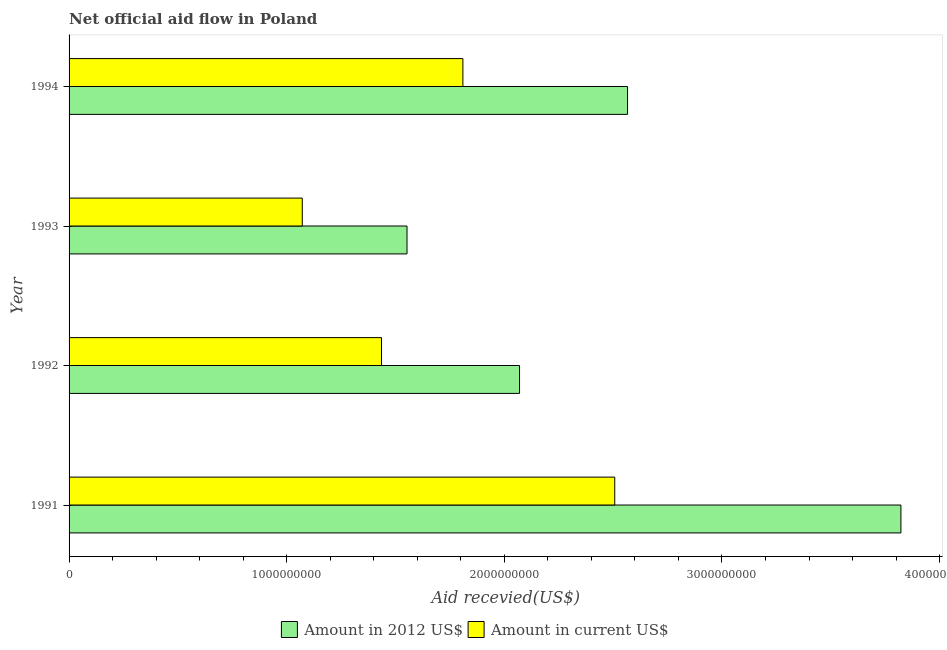How many different coloured bars are there?
Your response must be concise. 2. How many groups of bars are there?
Your answer should be very brief. 4. What is the amount of aid received(expressed in 2012 us$) in 1991?
Provide a short and direct response. 3.82e+09. Across all years, what is the maximum amount of aid received(expressed in us$)?
Your response must be concise. 2.51e+09. Across all years, what is the minimum amount of aid received(expressed in us$)?
Keep it short and to the point. 1.07e+09. What is the total amount of aid received(expressed in 2012 us$) in the graph?
Your answer should be compact. 1.00e+1. What is the difference between the amount of aid received(expressed in 2012 us$) in 1991 and that in 1994?
Ensure brevity in your answer.  1.26e+09. What is the difference between the amount of aid received(expressed in us$) in 1991 and the amount of aid received(expressed in 2012 us$) in 1994?
Offer a terse response. -5.88e+07. What is the average amount of aid received(expressed in 2012 us$) per year?
Offer a very short reply. 2.50e+09. In the year 1992, what is the difference between the amount of aid received(expressed in us$) and amount of aid received(expressed in 2012 us$)?
Your answer should be compact. -6.34e+08. In how many years, is the amount of aid received(expressed in us$) greater than 200000000 US$?
Offer a very short reply. 4. What is the ratio of the amount of aid received(expressed in 2012 us$) in 1992 to that in 1994?
Provide a succinct answer. 0.81. Is the difference between the amount of aid received(expressed in 2012 us$) in 1993 and 1994 greater than the difference between the amount of aid received(expressed in us$) in 1993 and 1994?
Give a very brief answer. No. What is the difference between the highest and the second highest amount of aid received(expressed in 2012 us$)?
Offer a terse response. 1.26e+09. What is the difference between the highest and the lowest amount of aid received(expressed in us$)?
Provide a succinct answer. 1.44e+09. In how many years, is the amount of aid received(expressed in 2012 us$) greater than the average amount of aid received(expressed in 2012 us$) taken over all years?
Ensure brevity in your answer.  2. Is the sum of the amount of aid received(expressed in us$) in 1991 and 1992 greater than the maximum amount of aid received(expressed in 2012 us$) across all years?
Ensure brevity in your answer.  Yes. What does the 1st bar from the top in 1991 represents?
Your response must be concise. Amount in current US$. What does the 1st bar from the bottom in 1991 represents?
Provide a succinct answer. Amount in 2012 US$. Are all the bars in the graph horizontal?
Keep it short and to the point. Yes. How many years are there in the graph?
Give a very brief answer. 4. What is the difference between two consecutive major ticks on the X-axis?
Your response must be concise. 1.00e+09. Are the values on the major ticks of X-axis written in scientific E-notation?
Provide a succinct answer. No. Does the graph contain any zero values?
Your response must be concise. No. Does the graph contain grids?
Your answer should be compact. No. How many legend labels are there?
Keep it short and to the point. 2. How are the legend labels stacked?
Offer a very short reply. Horizontal. What is the title of the graph?
Keep it short and to the point. Net official aid flow in Poland. Does "Under-five" appear as one of the legend labels in the graph?
Provide a short and direct response. No. What is the label or title of the X-axis?
Provide a short and direct response. Aid recevied(US$). What is the label or title of the Y-axis?
Make the answer very short. Year. What is the Aid recevied(US$) of Amount in 2012 US$ in 1991?
Provide a succinct answer. 3.82e+09. What is the Aid recevied(US$) of Amount in current US$ in 1991?
Your answer should be very brief. 2.51e+09. What is the Aid recevied(US$) of Amount in 2012 US$ in 1992?
Provide a short and direct response. 2.07e+09. What is the Aid recevied(US$) of Amount in current US$ in 1992?
Offer a terse response. 1.44e+09. What is the Aid recevied(US$) of Amount in 2012 US$ in 1993?
Give a very brief answer. 1.55e+09. What is the Aid recevied(US$) in Amount in current US$ in 1993?
Your answer should be compact. 1.07e+09. What is the Aid recevied(US$) in Amount in 2012 US$ in 1994?
Ensure brevity in your answer.  2.57e+09. What is the Aid recevied(US$) in Amount in current US$ in 1994?
Give a very brief answer. 1.81e+09. Across all years, what is the maximum Aid recevied(US$) of Amount in 2012 US$?
Give a very brief answer. 3.82e+09. Across all years, what is the maximum Aid recevied(US$) of Amount in current US$?
Offer a very short reply. 2.51e+09. Across all years, what is the minimum Aid recevied(US$) of Amount in 2012 US$?
Ensure brevity in your answer.  1.55e+09. Across all years, what is the minimum Aid recevied(US$) of Amount in current US$?
Your response must be concise. 1.07e+09. What is the total Aid recevied(US$) of Amount in 2012 US$ in the graph?
Keep it short and to the point. 1.00e+1. What is the total Aid recevied(US$) of Amount in current US$ in the graph?
Provide a succinct answer. 6.82e+09. What is the difference between the Aid recevied(US$) of Amount in 2012 US$ in 1991 and that in 1992?
Your answer should be compact. 1.75e+09. What is the difference between the Aid recevied(US$) in Amount in current US$ in 1991 and that in 1992?
Keep it short and to the point. 1.07e+09. What is the difference between the Aid recevied(US$) of Amount in 2012 US$ in 1991 and that in 1993?
Keep it short and to the point. 2.27e+09. What is the difference between the Aid recevied(US$) of Amount in current US$ in 1991 and that in 1993?
Give a very brief answer. 1.44e+09. What is the difference between the Aid recevied(US$) of Amount in 2012 US$ in 1991 and that in 1994?
Your response must be concise. 1.26e+09. What is the difference between the Aid recevied(US$) of Amount in current US$ in 1991 and that in 1994?
Your response must be concise. 6.98e+08. What is the difference between the Aid recevied(US$) of Amount in 2012 US$ in 1992 and that in 1993?
Keep it short and to the point. 5.17e+08. What is the difference between the Aid recevied(US$) in Amount in current US$ in 1992 and that in 1993?
Provide a succinct answer. 3.64e+08. What is the difference between the Aid recevied(US$) of Amount in 2012 US$ in 1992 and that in 1994?
Ensure brevity in your answer.  -4.96e+08. What is the difference between the Aid recevied(US$) in Amount in current US$ in 1992 and that in 1994?
Provide a short and direct response. -3.74e+08. What is the difference between the Aid recevied(US$) of Amount in 2012 US$ in 1993 and that in 1994?
Make the answer very short. -1.01e+09. What is the difference between the Aid recevied(US$) of Amount in current US$ in 1993 and that in 1994?
Keep it short and to the point. -7.38e+08. What is the difference between the Aid recevied(US$) in Amount in 2012 US$ in 1991 and the Aid recevied(US$) in Amount in current US$ in 1992?
Keep it short and to the point. 2.39e+09. What is the difference between the Aid recevied(US$) of Amount in 2012 US$ in 1991 and the Aid recevied(US$) of Amount in current US$ in 1993?
Provide a succinct answer. 2.75e+09. What is the difference between the Aid recevied(US$) in Amount in 2012 US$ in 1991 and the Aid recevied(US$) in Amount in current US$ in 1994?
Ensure brevity in your answer.  2.01e+09. What is the difference between the Aid recevied(US$) in Amount in 2012 US$ in 1992 and the Aid recevied(US$) in Amount in current US$ in 1993?
Give a very brief answer. 9.98e+08. What is the difference between the Aid recevied(US$) of Amount in 2012 US$ in 1992 and the Aid recevied(US$) of Amount in current US$ in 1994?
Offer a very short reply. 2.60e+08. What is the difference between the Aid recevied(US$) in Amount in 2012 US$ in 1993 and the Aid recevied(US$) in Amount in current US$ in 1994?
Provide a succinct answer. -2.57e+08. What is the average Aid recevied(US$) in Amount in 2012 US$ per year?
Your answer should be very brief. 2.50e+09. What is the average Aid recevied(US$) in Amount in current US$ per year?
Your answer should be compact. 1.71e+09. In the year 1991, what is the difference between the Aid recevied(US$) in Amount in 2012 US$ and Aid recevied(US$) in Amount in current US$?
Offer a terse response. 1.31e+09. In the year 1992, what is the difference between the Aid recevied(US$) in Amount in 2012 US$ and Aid recevied(US$) in Amount in current US$?
Your response must be concise. 6.34e+08. In the year 1993, what is the difference between the Aid recevied(US$) in Amount in 2012 US$ and Aid recevied(US$) in Amount in current US$?
Ensure brevity in your answer.  4.81e+08. In the year 1994, what is the difference between the Aid recevied(US$) in Amount in 2012 US$ and Aid recevied(US$) in Amount in current US$?
Keep it short and to the point. 7.57e+08. What is the ratio of the Aid recevied(US$) of Amount in 2012 US$ in 1991 to that in 1992?
Your answer should be very brief. 1.85. What is the ratio of the Aid recevied(US$) of Amount in current US$ in 1991 to that in 1992?
Offer a terse response. 1.75. What is the ratio of the Aid recevied(US$) in Amount in 2012 US$ in 1991 to that in 1993?
Ensure brevity in your answer.  2.46. What is the ratio of the Aid recevied(US$) in Amount in current US$ in 1991 to that in 1993?
Provide a succinct answer. 2.34. What is the ratio of the Aid recevied(US$) of Amount in 2012 US$ in 1991 to that in 1994?
Provide a short and direct response. 1.49. What is the ratio of the Aid recevied(US$) in Amount in current US$ in 1991 to that in 1994?
Keep it short and to the point. 1.39. What is the ratio of the Aid recevied(US$) in Amount in 2012 US$ in 1992 to that in 1993?
Offer a very short reply. 1.33. What is the ratio of the Aid recevied(US$) in Amount in current US$ in 1992 to that in 1993?
Offer a very short reply. 1.34. What is the ratio of the Aid recevied(US$) in Amount in 2012 US$ in 1992 to that in 1994?
Give a very brief answer. 0.81. What is the ratio of the Aid recevied(US$) in Amount in current US$ in 1992 to that in 1994?
Your answer should be compact. 0.79. What is the ratio of the Aid recevied(US$) of Amount in 2012 US$ in 1993 to that in 1994?
Offer a very short reply. 0.61. What is the ratio of the Aid recevied(US$) of Amount in current US$ in 1993 to that in 1994?
Provide a succinct answer. 0.59. What is the difference between the highest and the second highest Aid recevied(US$) in Amount in 2012 US$?
Give a very brief answer. 1.26e+09. What is the difference between the highest and the second highest Aid recevied(US$) of Amount in current US$?
Make the answer very short. 6.98e+08. What is the difference between the highest and the lowest Aid recevied(US$) of Amount in 2012 US$?
Offer a very short reply. 2.27e+09. What is the difference between the highest and the lowest Aid recevied(US$) in Amount in current US$?
Provide a short and direct response. 1.44e+09. 